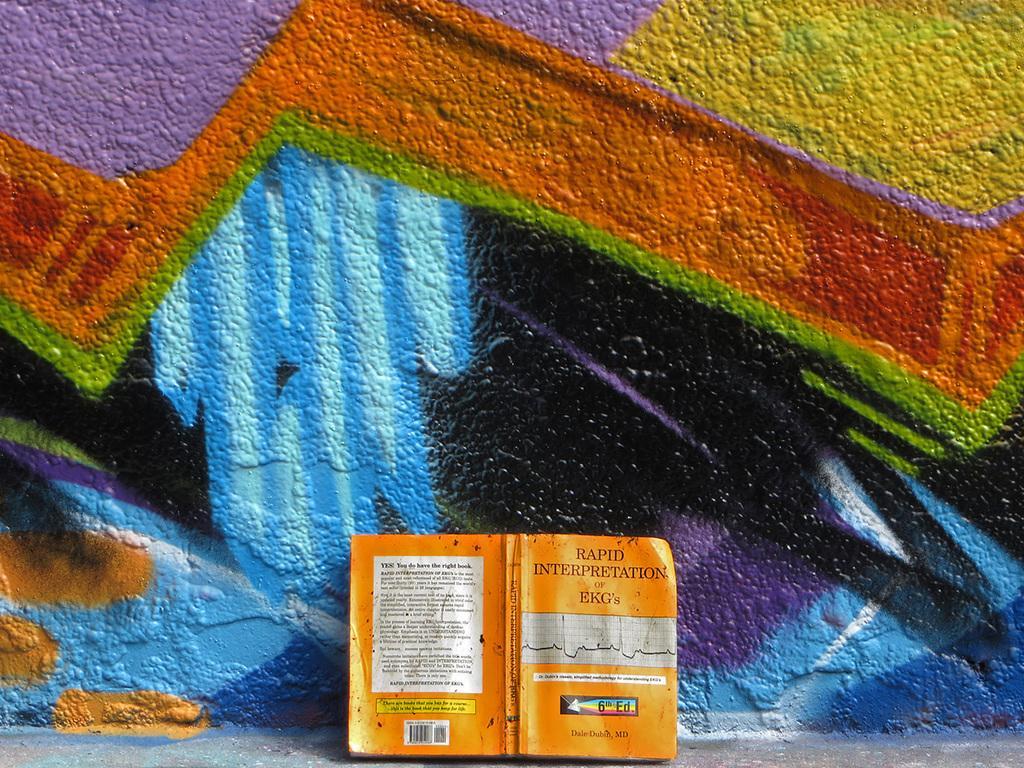In one or two sentences, can you explain what this image depicts? In this image we can see a book and a painted wall. 